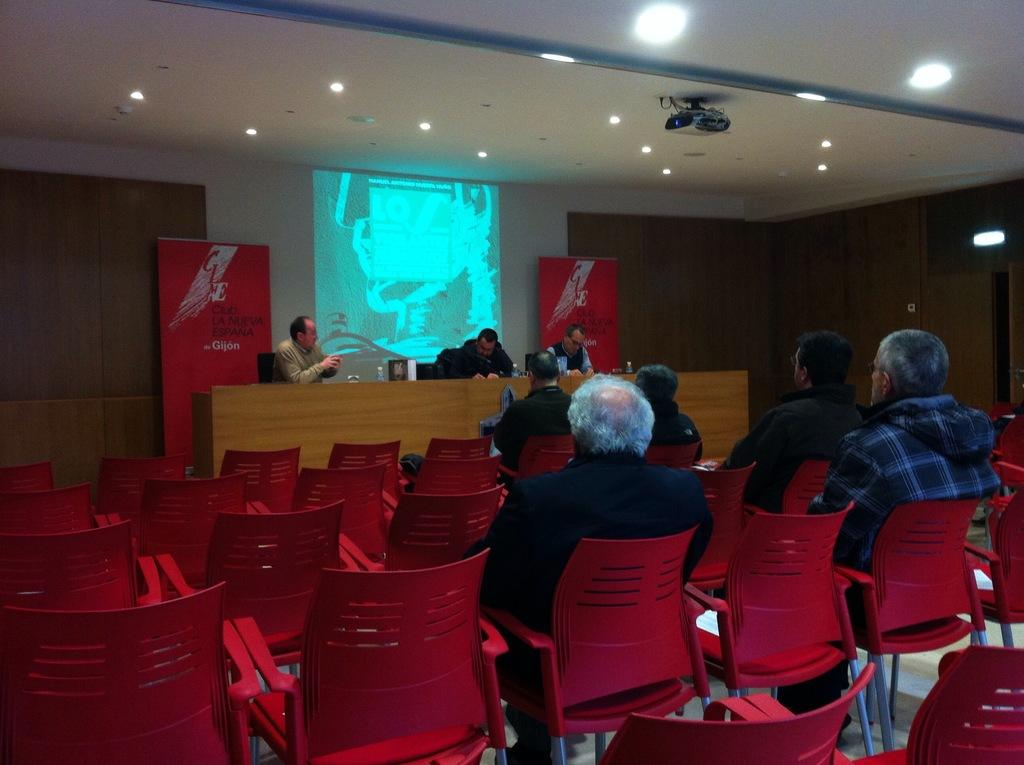What are the people in the image doing? The people in the image are sitting on chairs. What can be seen in the image besides the people? There is a desk, objects on the desk, a projector, and a wooden wall in the image. What is the purpose of the projector in the image? The projector is likely used for displaying visuals or presentations. What type of material is the wall made of? The wall in the image is made of wood. What is present on the ceiling in the image? The ceiling in the image has lights. What type of butter is being used to write on the desk in the image? There is no butter present in the image, and therefore it cannot be used for writing on the desk. 